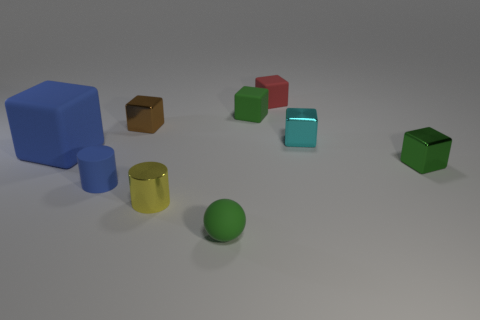Subtract all cyan cubes. How many cubes are left? 5 Subtract all blue rubber cubes. How many cubes are left? 5 Subtract all purple blocks. Subtract all blue cylinders. How many blocks are left? 6 Add 1 small metal cubes. How many objects exist? 10 Subtract all cylinders. How many objects are left? 7 Add 7 large yellow balls. How many large yellow balls exist? 7 Subtract 1 blue blocks. How many objects are left? 8 Subtract all gray shiny objects. Subtract all yellow objects. How many objects are left? 8 Add 3 small cyan metallic blocks. How many small cyan metallic blocks are left? 4 